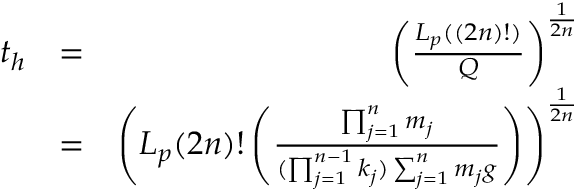<formula> <loc_0><loc_0><loc_500><loc_500>\begin{array} { r l r } { t _ { h } } & { = } & { \left ( \frac { L _ { p } ( ( 2 n ) ! ) } { Q } \right ) ^ { \frac { 1 } { 2 n } } } \\ & { = } & { \left ( L _ { p } ( 2 n ) ! \left ( \frac { \prod _ { j = 1 } ^ { n } m _ { j } } { ( \prod _ { j = 1 } ^ { n - 1 } k _ { j } ) \sum _ { j = 1 } ^ { n } m _ { j } g } \right ) \right ) ^ { \frac { 1 } { 2 n } } } \end{array}</formula> 